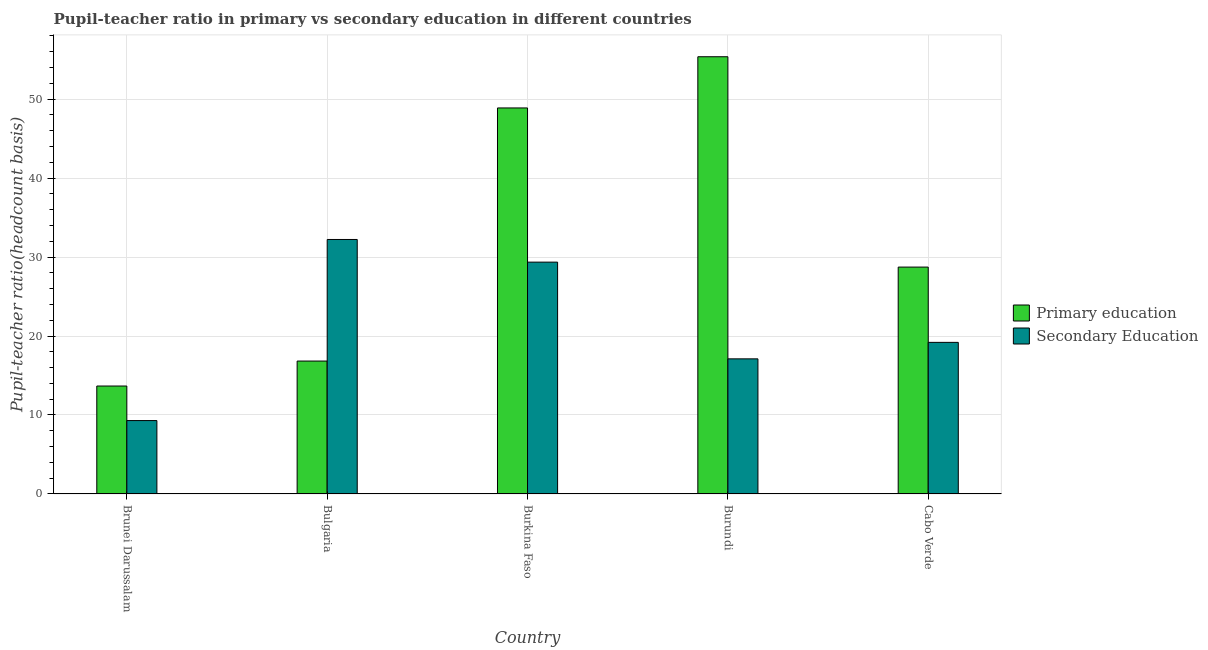How many different coloured bars are there?
Provide a short and direct response. 2. How many groups of bars are there?
Give a very brief answer. 5. Are the number of bars per tick equal to the number of legend labels?
Ensure brevity in your answer.  Yes. How many bars are there on the 4th tick from the left?
Provide a short and direct response. 2. What is the pupil teacher ratio on secondary education in Burkina Faso?
Provide a short and direct response. 29.35. Across all countries, what is the maximum pupil-teacher ratio in primary education?
Your answer should be compact. 55.36. Across all countries, what is the minimum pupil teacher ratio on secondary education?
Offer a very short reply. 9.29. In which country was the pupil-teacher ratio in primary education maximum?
Provide a succinct answer. Burundi. In which country was the pupil-teacher ratio in primary education minimum?
Your answer should be compact. Brunei Darussalam. What is the total pupil teacher ratio on secondary education in the graph?
Your answer should be very brief. 107.17. What is the difference between the pupil teacher ratio on secondary education in Burkina Faso and that in Cabo Verde?
Your response must be concise. 10.16. What is the difference between the pupil teacher ratio on secondary education in Burundi and the pupil-teacher ratio in primary education in Cabo Verde?
Offer a terse response. -11.62. What is the average pupil teacher ratio on secondary education per country?
Make the answer very short. 21.43. What is the difference between the pupil teacher ratio on secondary education and pupil-teacher ratio in primary education in Bulgaria?
Offer a terse response. 15.39. What is the ratio of the pupil teacher ratio on secondary education in Brunei Darussalam to that in Burundi?
Give a very brief answer. 0.54. Is the difference between the pupil teacher ratio on secondary education in Brunei Darussalam and Cabo Verde greater than the difference between the pupil-teacher ratio in primary education in Brunei Darussalam and Cabo Verde?
Your answer should be very brief. Yes. What is the difference between the highest and the second highest pupil-teacher ratio in primary education?
Give a very brief answer. 6.48. What is the difference between the highest and the lowest pupil teacher ratio on secondary education?
Make the answer very short. 22.93. Is the sum of the pupil teacher ratio on secondary education in Bulgaria and Burkina Faso greater than the maximum pupil-teacher ratio in primary education across all countries?
Offer a very short reply. Yes. What does the 1st bar from the left in Brunei Darussalam represents?
Offer a very short reply. Primary education. What is the difference between two consecutive major ticks on the Y-axis?
Give a very brief answer. 10. Are the values on the major ticks of Y-axis written in scientific E-notation?
Ensure brevity in your answer.  No. Does the graph contain grids?
Offer a terse response. Yes. Where does the legend appear in the graph?
Ensure brevity in your answer.  Center right. How many legend labels are there?
Make the answer very short. 2. How are the legend labels stacked?
Provide a short and direct response. Vertical. What is the title of the graph?
Make the answer very short. Pupil-teacher ratio in primary vs secondary education in different countries. What is the label or title of the Y-axis?
Offer a very short reply. Pupil-teacher ratio(headcount basis). What is the Pupil-teacher ratio(headcount basis) in Primary education in Brunei Darussalam?
Offer a terse response. 13.67. What is the Pupil-teacher ratio(headcount basis) in Secondary Education in Brunei Darussalam?
Provide a short and direct response. 9.29. What is the Pupil-teacher ratio(headcount basis) in Primary education in Bulgaria?
Ensure brevity in your answer.  16.83. What is the Pupil-teacher ratio(headcount basis) in Secondary Education in Bulgaria?
Ensure brevity in your answer.  32.22. What is the Pupil-teacher ratio(headcount basis) of Primary education in Burkina Faso?
Make the answer very short. 48.88. What is the Pupil-teacher ratio(headcount basis) in Secondary Education in Burkina Faso?
Offer a very short reply. 29.35. What is the Pupil-teacher ratio(headcount basis) of Primary education in Burundi?
Offer a terse response. 55.36. What is the Pupil-teacher ratio(headcount basis) in Secondary Education in Burundi?
Give a very brief answer. 17.11. What is the Pupil-teacher ratio(headcount basis) in Primary education in Cabo Verde?
Your response must be concise. 28.73. What is the Pupil-teacher ratio(headcount basis) in Secondary Education in Cabo Verde?
Your response must be concise. 19.2. Across all countries, what is the maximum Pupil-teacher ratio(headcount basis) in Primary education?
Your response must be concise. 55.36. Across all countries, what is the maximum Pupil-teacher ratio(headcount basis) of Secondary Education?
Your response must be concise. 32.22. Across all countries, what is the minimum Pupil-teacher ratio(headcount basis) of Primary education?
Offer a terse response. 13.67. Across all countries, what is the minimum Pupil-teacher ratio(headcount basis) of Secondary Education?
Provide a short and direct response. 9.29. What is the total Pupil-teacher ratio(headcount basis) in Primary education in the graph?
Your response must be concise. 163.46. What is the total Pupil-teacher ratio(headcount basis) in Secondary Education in the graph?
Ensure brevity in your answer.  107.17. What is the difference between the Pupil-teacher ratio(headcount basis) in Primary education in Brunei Darussalam and that in Bulgaria?
Keep it short and to the point. -3.16. What is the difference between the Pupil-teacher ratio(headcount basis) of Secondary Education in Brunei Darussalam and that in Bulgaria?
Ensure brevity in your answer.  -22.93. What is the difference between the Pupil-teacher ratio(headcount basis) in Primary education in Brunei Darussalam and that in Burkina Faso?
Your answer should be very brief. -35.21. What is the difference between the Pupil-teacher ratio(headcount basis) in Secondary Education in Brunei Darussalam and that in Burkina Faso?
Offer a very short reply. -20.06. What is the difference between the Pupil-teacher ratio(headcount basis) of Primary education in Brunei Darussalam and that in Burundi?
Ensure brevity in your answer.  -41.69. What is the difference between the Pupil-teacher ratio(headcount basis) of Secondary Education in Brunei Darussalam and that in Burundi?
Keep it short and to the point. -7.81. What is the difference between the Pupil-teacher ratio(headcount basis) in Primary education in Brunei Darussalam and that in Cabo Verde?
Offer a very short reply. -15.06. What is the difference between the Pupil-teacher ratio(headcount basis) in Secondary Education in Brunei Darussalam and that in Cabo Verde?
Make the answer very short. -9.9. What is the difference between the Pupil-teacher ratio(headcount basis) of Primary education in Bulgaria and that in Burkina Faso?
Your answer should be compact. -32.05. What is the difference between the Pupil-teacher ratio(headcount basis) in Secondary Education in Bulgaria and that in Burkina Faso?
Offer a terse response. 2.87. What is the difference between the Pupil-teacher ratio(headcount basis) of Primary education in Bulgaria and that in Burundi?
Offer a terse response. -38.53. What is the difference between the Pupil-teacher ratio(headcount basis) of Secondary Education in Bulgaria and that in Burundi?
Your answer should be compact. 15.11. What is the difference between the Pupil-teacher ratio(headcount basis) of Primary education in Bulgaria and that in Cabo Verde?
Offer a very short reply. -11.9. What is the difference between the Pupil-teacher ratio(headcount basis) of Secondary Education in Bulgaria and that in Cabo Verde?
Offer a very short reply. 13.03. What is the difference between the Pupil-teacher ratio(headcount basis) of Primary education in Burkina Faso and that in Burundi?
Offer a very short reply. -6.48. What is the difference between the Pupil-teacher ratio(headcount basis) in Secondary Education in Burkina Faso and that in Burundi?
Provide a short and direct response. 12.24. What is the difference between the Pupil-teacher ratio(headcount basis) in Primary education in Burkina Faso and that in Cabo Verde?
Your response must be concise. 20.15. What is the difference between the Pupil-teacher ratio(headcount basis) in Secondary Education in Burkina Faso and that in Cabo Verde?
Your answer should be very brief. 10.16. What is the difference between the Pupil-teacher ratio(headcount basis) of Primary education in Burundi and that in Cabo Verde?
Give a very brief answer. 26.63. What is the difference between the Pupil-teacher ratio(headcount basis) in Secondary Education in Burundi and that in Cabo Verde?
Provide a short and direct response. -2.09. What is the difference between the Pupil-teacher ratio(headcount basis) of Primary education in Brunei Darussalam and the Pupil-teacher ratio(headcount basis) of Secondary Education in Bulgaria?
Make the answer very short. -18.56. What is the difference between the Pupil-teacher ratio(headcount basis) in Primary education in Brunei Darussalam and the Pupil-teacher ratio(headcount basis) in Secondary Education in Burkina Faso?
Your answer should be very brief. -15.69. What is the difference between the Pupil-teacher ratio(headcount basis) in Primary education in Brunei Darussalam and the Pupil-teacher ratio(headcount basis) in Secondary Education in Burundi?
Keep it short and to the point. -3.44. What is the difference between the Pupil-teacher ratio(headcount basis) of Primary education in Brunei Darussalam and the Pupil-teacher ratio(headcount basis) of Secondary Education in Cabo Verde?
Offer a very short reply. -5.53. What is the difference between the Pupil-teacher ratio(headcount basis) of Primary education in Bulgaria and the Pupil-teacher ratio(headcount basis) of Secondary Education in Burkina Faso?
Provide a succinct answer. -12.52. What is the difference between the Pupil-teacher ratio(headcount basis) of Primary education in Bulgaria and the Pupil-teacher ratio(headcount basis) of Secondary Education in Burundi?
Ensure brevity in your answer.  -0.28. What is the difference between the Pupil-teacher ratio(headcount basis) of Primary education in Bulgaria and the Pupil-teacher ratio(headcount basis) of Secondary Education in Cabo Verde?
Provide a succinct answer. -2.37. What is the difference between the Pupil-teacher ratio(headcount basis) in Primary education in Burkina Faso and the Pupil-teacher ratio(headcount basis) in Secondary Education in Burundi?
Your answer should be very brief. 31.77. What is the difference between the Pupil-teacher ratio(headcount basis) of Primary education in Burkina Faso and the Pupil-teacher ratio(headcount basis) of Secondary Education in Cabo Verde?
Give a very brief answer. 29.68. What is the difference between the Pupil-teacher ratio(headcount basis) in Primary education in Burundi and the Pupil-teacher ratio(headcount basis) in Secondary Education in Cabo Verde?
Give a very brief answer. 36.16. What is the average Pupil-teacher ratio(headcount basis) in Primary education per country?
Provide a succinct answer. 32.69. What is the average Pupil-teacher ratio(headcount basis) in Secondary Education per country?
Ensure brevity in your answer.  21.43. What is the difference between the Pupil-teacher ratio(headcount basis) of Primary education and Pupil-teacher ratio(headcount basis) of Secondary Education in Brunei Darussalam?
Give a very brief answer. 4.37. What is the difference between the Pupil-teacher ratio(headcount basis) of Primary education and Pupil-teacher ratio(headcount basis) of Secondary Education in Bulgaria?
Your answer should be very brief. -15.39. What is the difference between the Pupil-teacher ratio(headcount basis) in Primary education and Pupil-teacher ratio(headcount basis) in Secondary Education in Burkina Faso?
Offer a very short reply. 19.52. What is the difference between the Pupil-teacher ratio(headcount basis) of Primary education and Pupil-teacher ratio(headcount basis) of Secondary Education in Burundi?
Provide a short and direct response. 38.25. What is the difference between the Pupil-teacher ratio(headcount basis) in Primary education and Pupil-teacher ratio(headcount basis) in Secondary Education in Cabo Verde?
Your response must be concise. 9.53. What is the ratio of the Pupil-teacher ratio(headcount basis) of Primary education in Brunei Darussalam to that in Bulgaria?
Provide a succinct answer. 0.81. What is the ratio of the Pupil-teacher ratio(headcount basis) in Secondary Education in Brunei Darussalam to that in Bulgaria?
Provide a short and direct response. 0.29. What is the ratio of the Pupil-teacher ratio(headcount basis) of Primary education in Brunei Darussalam to that in Burkina Faso?
Provide a short and direct response. 0.28. What is the ratio of the Pupil-teacher ratio(headcount basis) of Secondary Education in Brunei Darussalam to that in Burkina Faso?
Offer a terse response. 0.32. What is the ratio of the Pupil-teacher ratio(headcount basis) of Primary education in Brunei Darussalam to that in Burundi?
Ensure brevity in your answer.  0.25. What is the ratio of the Pupil-teacher ratio(headcount basis) in Secondary Education in Brunei Darussalam to that in Burundi?
Your response must be concise. 0.54. What is the ratio of the Pupil-teacher ratio(headcount basis) of Primary education in Brunei Darussalam to that in Cabo Verde?
Ensure brevity in your answer.  0.48. What is the ratio of the Pupil-teacher ratio(headcount basis) of Secondary Education in Brunei Darussalam to that in Cabo Verde?
Provide a short and direct response. 0.48. What is the ratio of the Pupil-teacher ratio(headcount basis) of Primary education in Bulgaria to that in Burkina Faso?
Keep it short and to the point. 0.34. What is the ratio of the Pupil-teacher ratio(headcount basis) in Secondary Education in Bulgaria to that in Burkina Faso?
Your answer should be compact. 1.1. What is the ratio of the Pupil-teacher ratio(headcount basis) of Primary education in Bulgaria to that in Burundi?
Keep it short and to the point. 0.3. What is the ratio of the Pupil-teacher ratio(headcount basis) in Secondary Education in Bulgaria to that in Burundi?
Keep it short and to the point. 1.88. What is the ratio of the Pupil-teacher ratio(headcount basis) in Primary education in Bulgaria to that in Cabo Verde?
Your answer should be very brief. 0.59. What is the ratio of the Pupil-teacher ratio(headcount basis) of Secondary Education in Bulgaria to that in Cabo Verde?
Your answer should be very brief. 1.68. What is the ratio of the Pupil-teacher ratio(headcount basis) in Primary education in Burkina Faso to that in Burundi?
Your response must be concise. 0.88. What is the ratio of the Pupil-teacher ratio(headcount basis) in Secondary Education in Burkina Faso to that in Burundi?
Your answer should be very brief. 1.72. What is the ratio of the Pupil-teacher ratio(headcount basis) of Primary education in Burkina Faso to that in Cabo Verde?
Offer a terse response. 1.7. What is the ratio of the Pupil-teacher ratio(headcount basis) in Secondary Education in Burkina Faso to that in Cabo Verde?
Make the answer very short. 1.53. What is the ratio of the Pupil-teacher ratio(headcount basis) in Primary education in Burundi to that in Cabo Verde?
Provide a succinct answer. 1.93. What is the ratio of the Pupil-teacher ratio(headcount basis) of Secondary Education in Burundi to that in Cabo Verde?
Make the answer very short. 0.89. What is the difference between the highest and the second highest Pupil-teacher ratio(headcount basis) of Primary education?
Your answer should be compact. 6.48. What is the difference between the highest and the second highest Pupil-teacher ratio(headcount basis) in Secondary Education?
Give a very brief answer. 2.87. What is the difference between the highest and the lowest Pupil-teacher ratio(headcount basis) in Primary education?
Your response must be concise. 41.69. What is the difference between the highest and the lowest Pupil-teacher ratio(headcount basis) in Secondary Education?
Make the answer very short. 22.93. 